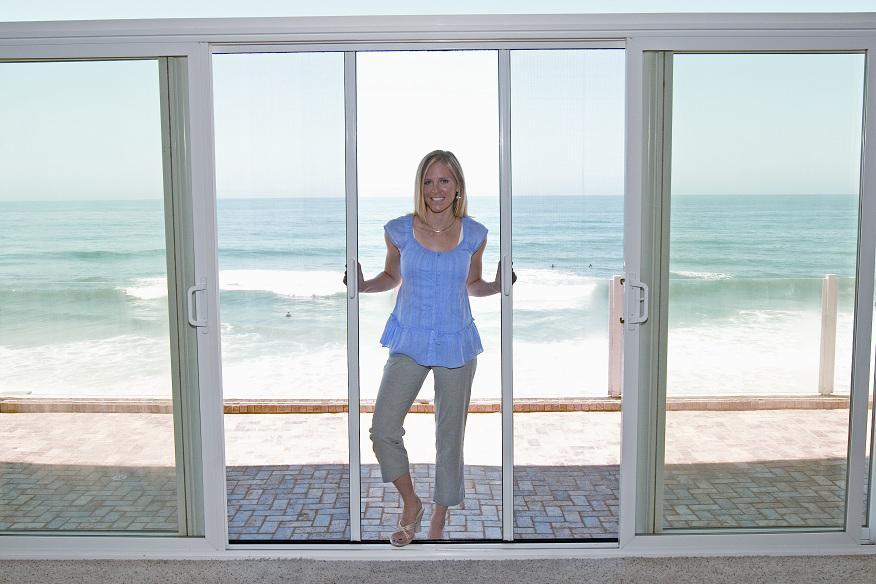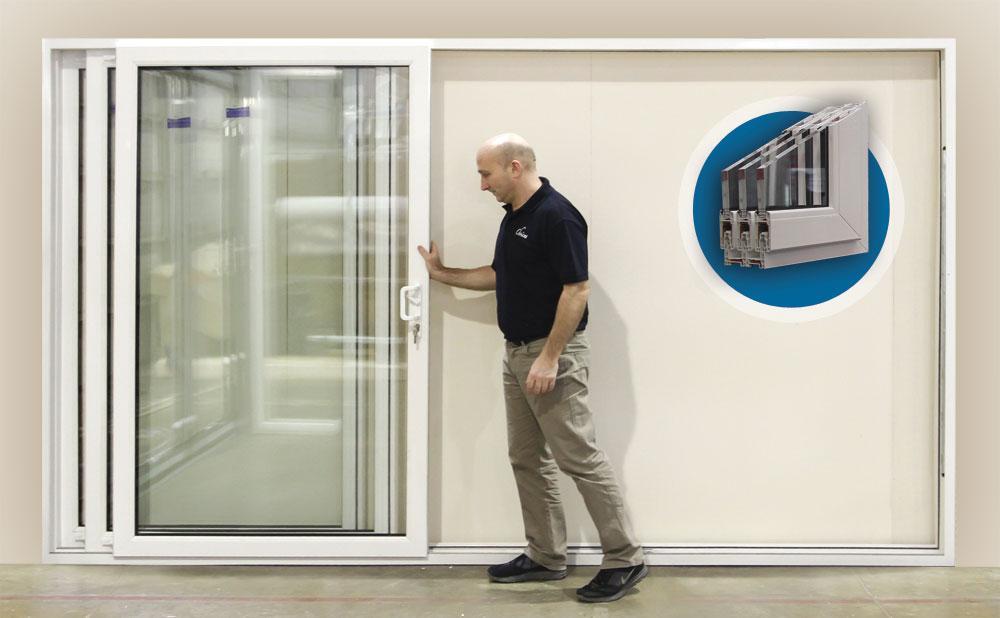The first image is the image on the left, the second image is the image on the right. Evaluate the accuracy of this statement regarding the images: "An image shows one woman standing and touching a sliding door element.". Is it true? Answer yes or no. Yes. The first image is the image on the left, the second image is the image on the right. For the images displayed, is the sentence "A woman is standing by the opening in the image on the left." factually correct? Answer yes or no. Yes. 